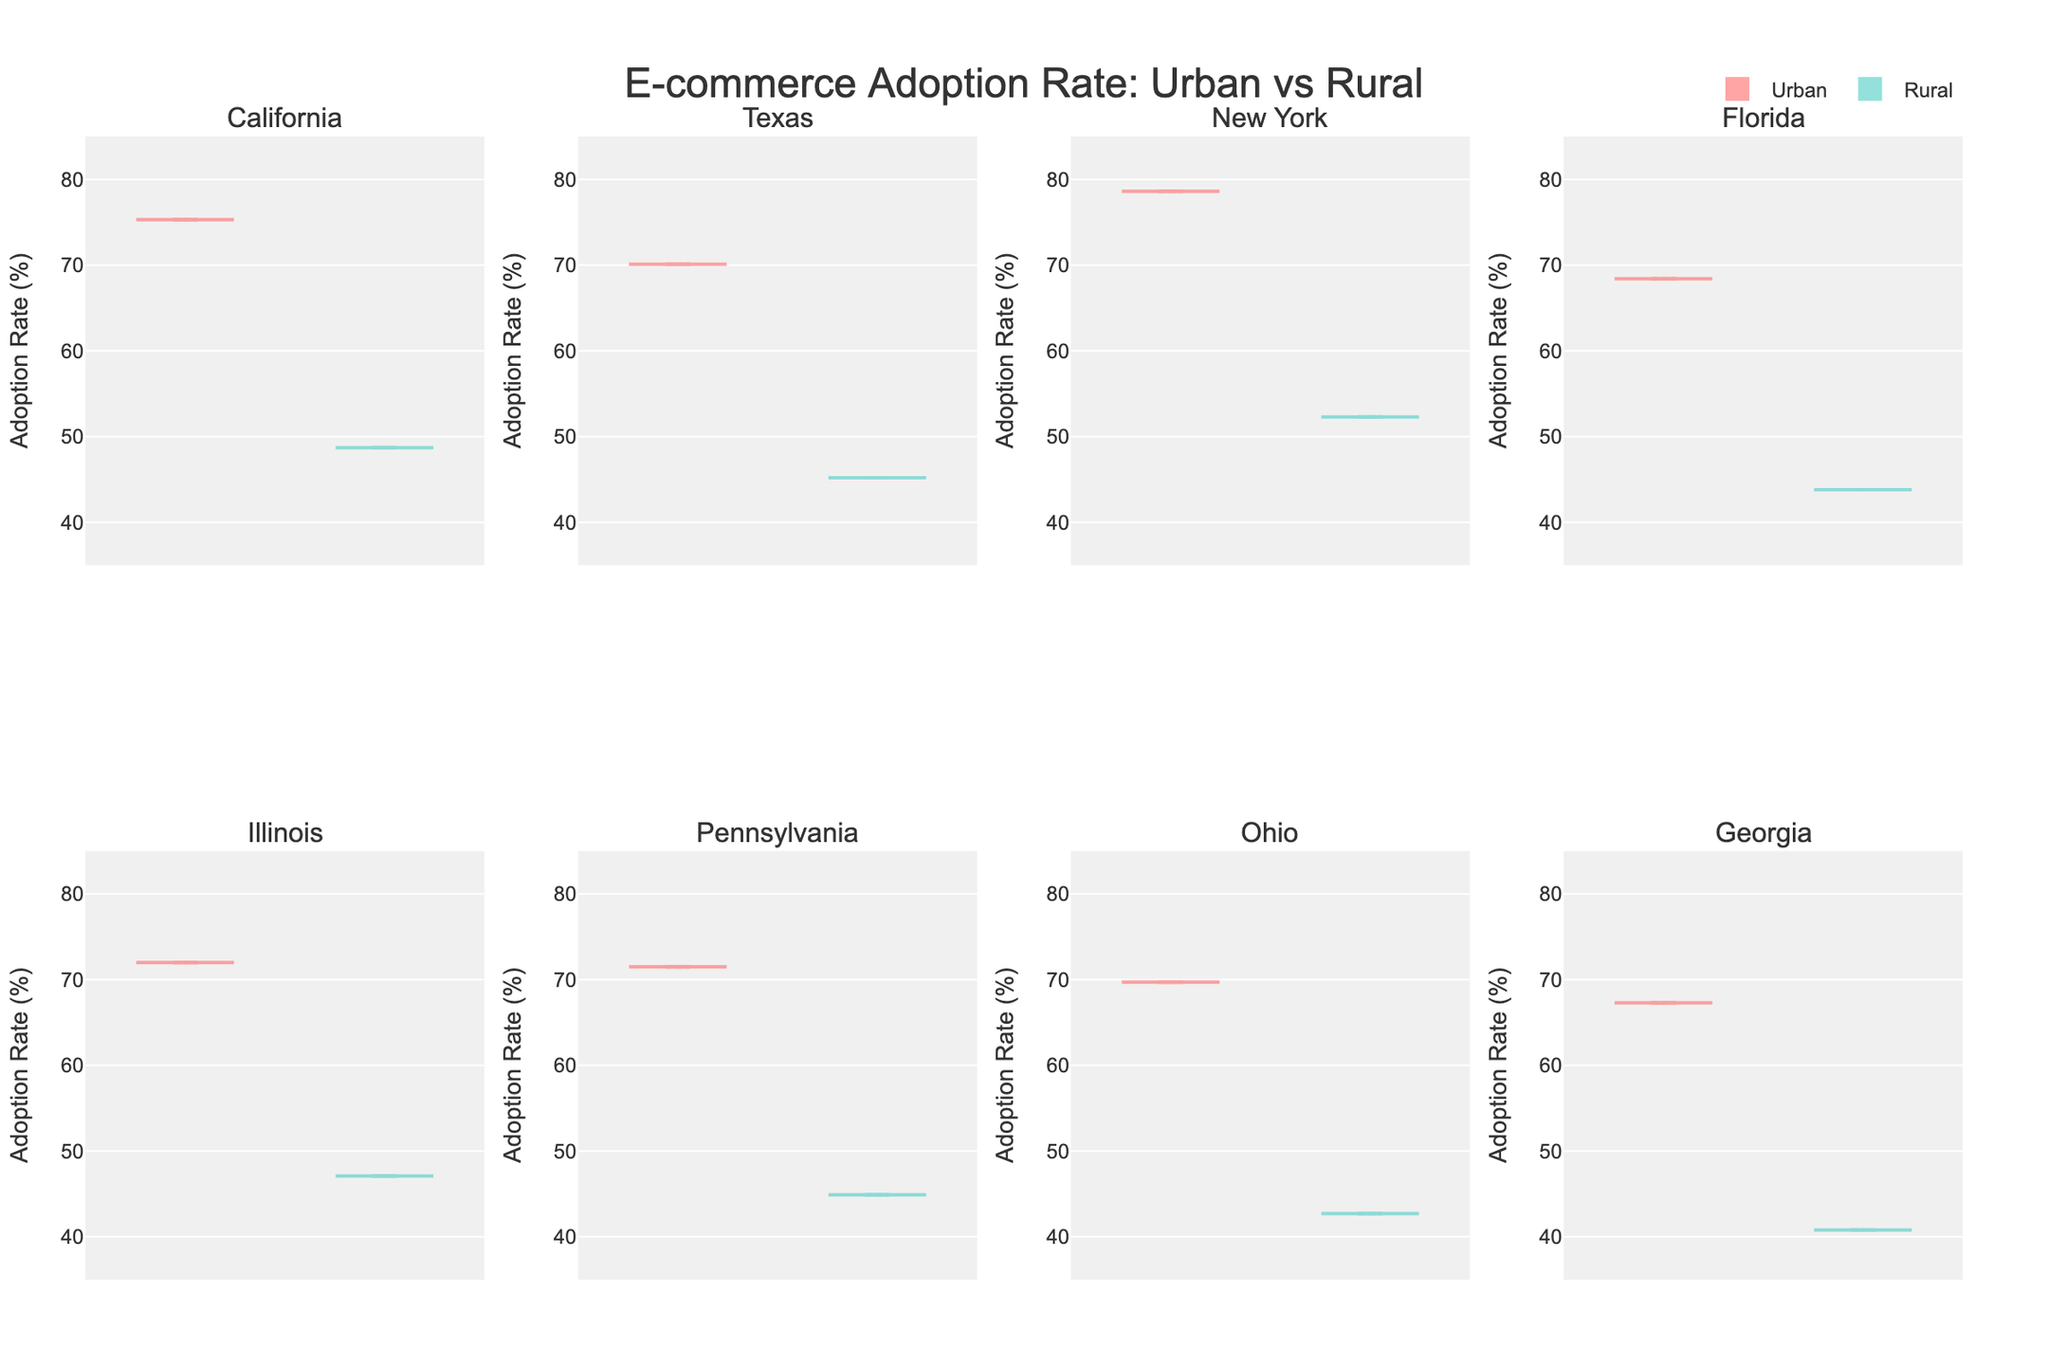What is the title of the figure? The title of the figure is located at the top center and it clearly states the main topic of the plot.
Answer: E-commerce Adoption Rate: Urban vs Rural How many violin plots are there in total? Each state has two violin plots (one for Urban and one for Rural), and there are 7 states shown. Hence, the total number of violin plots is 7 states * 2 plots = 14.
Answer: 14 Which state has the highest urban adoption rate? Look at the highest points of the violin plots labeled "Urban" across all states. The tallest point is in the plot for New York.
Answer: New York Compare the adoption rates in urban and rural areas for Illinois. Which is higher? Both the Urban and Rural rates for Illinois can be compared. The Urban plot has a higher median and distribution compared to the Rural plot.
Answer: Urban Among the provided states, which urban region has the lowest adoption rate? Examine the lowest point of the violin plots labeled "Urban" across all states. The lowest point is found in the plot for Georgia.
Answer: Georgia What is the average adoption rate difference between urban and rural areas in New York? Calculate the difference between the urban (78.6) and rural (52.3) adoption rates for New York. Then, sum the numbers and divide by 2.
Answer: 13.15 Is there any state where the rural adoption rate is higher than 50%? Check the highest value in each rural violin plot. Only New York’s rural plot shows an adoption rate higher than 50%.
Answer: Yes, New York Which state shows the smallest difference between urban and rural adoption rates? Calculate the differences for each state: 
California (75.3 - 48.7 = 26.6), Texas (70.1 - 45.2 = 24.9), New York (78.6 - 52.3 = 26.3), Florida (68.4 - 43.8 = 24.6), Illinois (72.0 - 47.1 = 24.9), Pennsylvania (71.5 - 44.9 = 26.6), Georgia (67.3 - 40.8 = 26.5). Florida has the smallest difference.
Answer: Florida How do the adoption rates in urban areas of Ohio compare to those in urban areas of Texas? Compare the median values by looking at the height of Ohio’s urban plot versus Texas's urban plot. Ohio's plot seems slightly lower.
Answer: Ohio is lower Which regions, urban or rural, generally have a higher mean adoption rate across all states? In general, look at the central tendency (mean lines) of all Urban versus Rural plots. The Urban plots consistently have higher means compared to the Rural plots.
Answer: Urban 